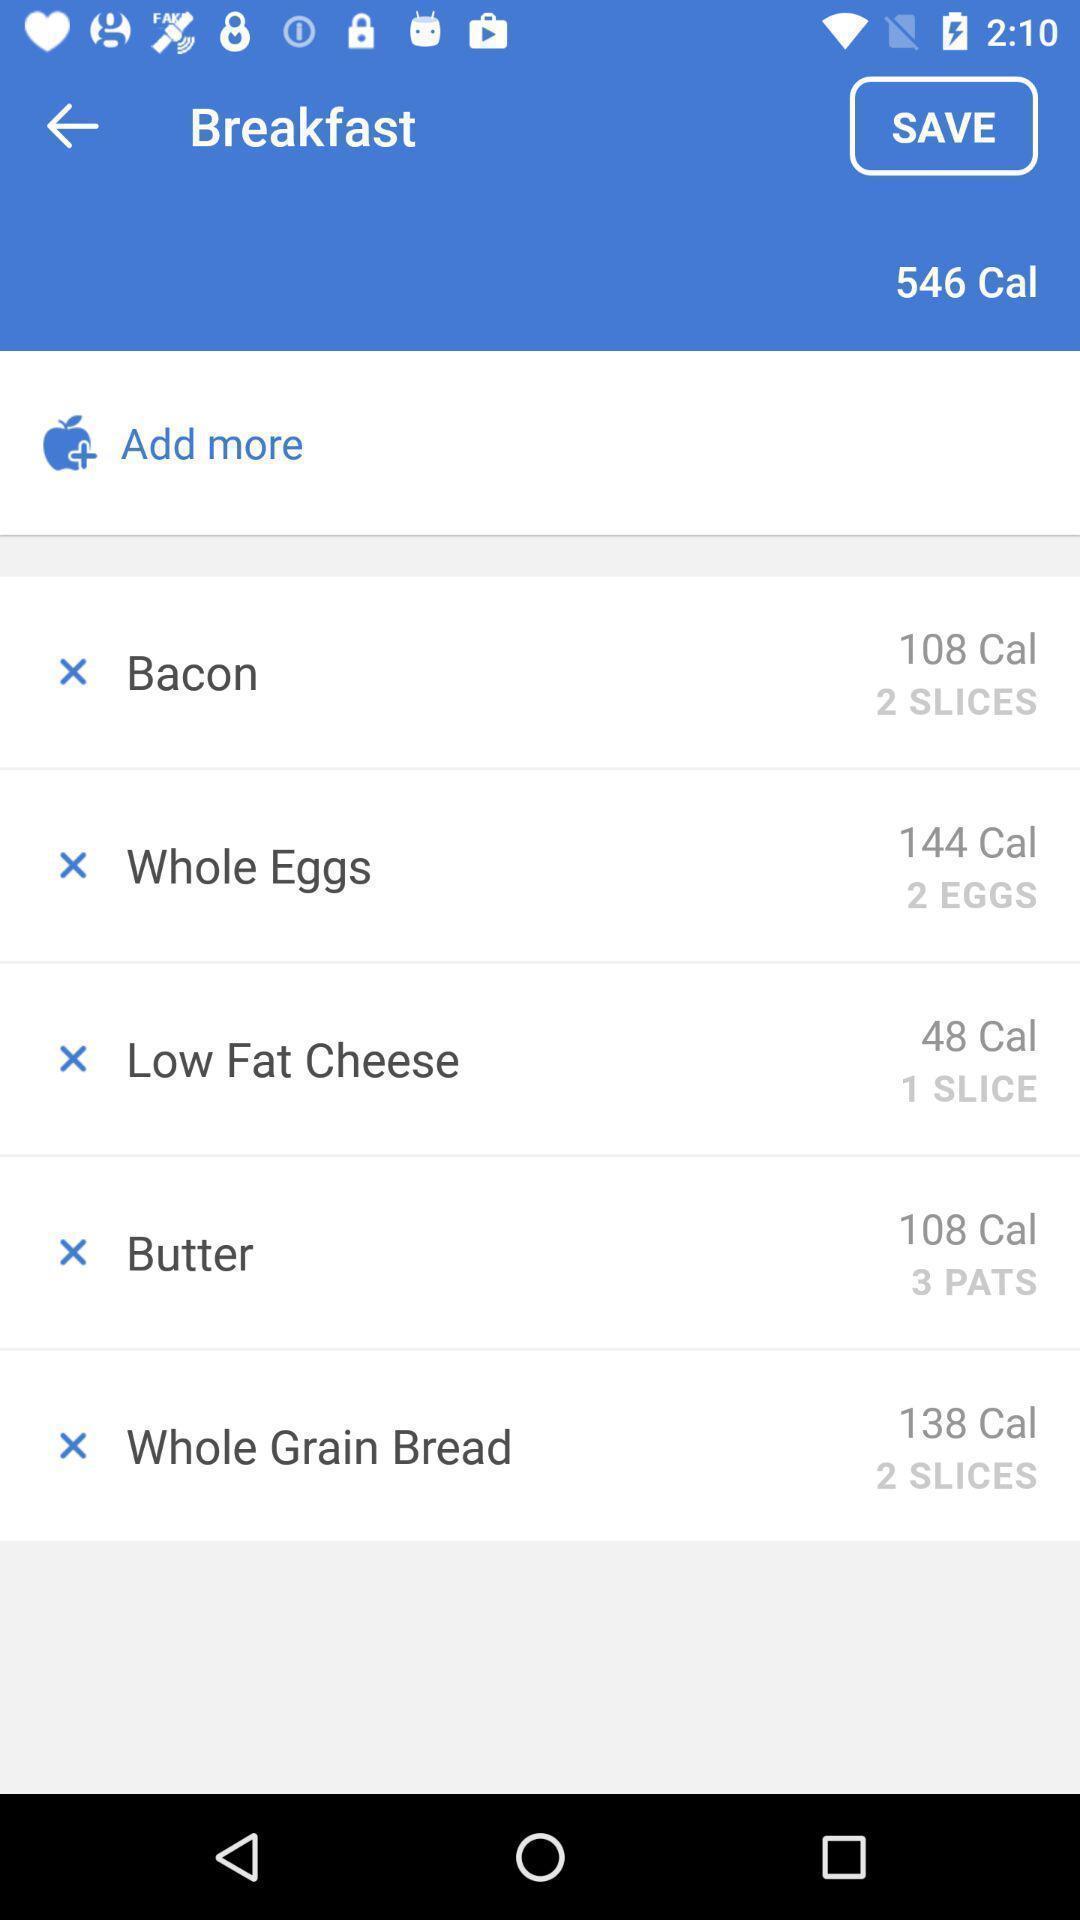Describe the visual elements of this screenshot. Screen shows multiple options in a food application. 